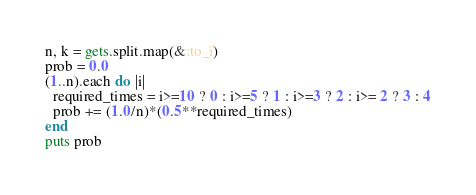<code> <loc_0><loc_0><loc_500><loc_500><_Ruby_>n, k = gets.split.map(&:to_i)
prob = 0.0
(1..n).each do |i|
  required_times = i>=10 ? 0 : i>=5 ? 1 : i>=3 ? 2 : i>= 2 ? 3 : 4
  prob += (1.0/n)*(0.5**required_times)
end
puts prob</code> 